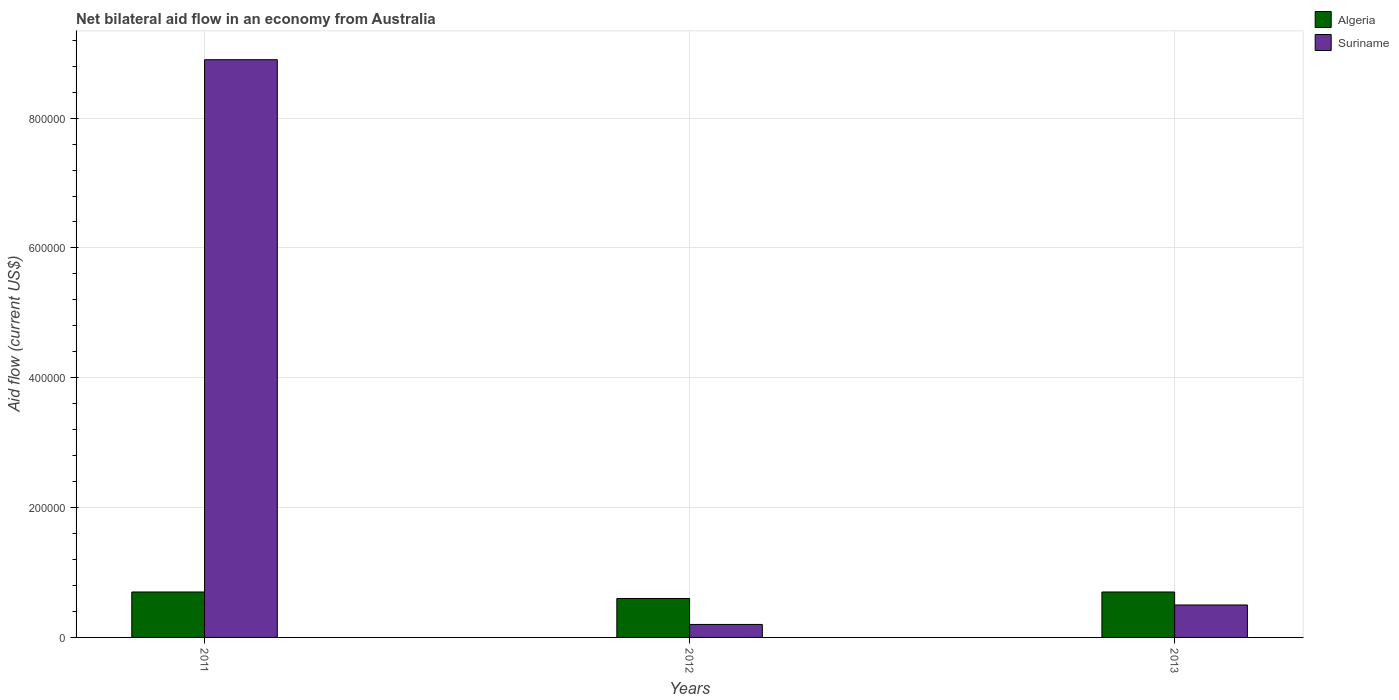Are the number of bars per tick equal to the number of legend labels?
Give a very brief answer. Yes. How many bars are there on the 1st tick from the right?
Your answer should be compact. 2. What is the label of the 3rd group of bars from the left?
Make the answer very short. 2013. Across all years, what is the maximum net bilateral aid flow in Suriname?
Your answer should be very brief. 8.90e+05. Across all years, what is the minimum net bilateral aid flow in Algeria?
Make the answer very short. 6.00e+04. In which year was the net bilateral aid flow in Suriname maximum?
Your answer should be very brief. 2011. What is the total net bilateral aid flow in Algeria in the graph?
Offer a very short reply. 2.00e+05. What is the difference between the net bilateral aid flow in Algeria in 2011 and the net bilateral aid flow in Suriname in 2012?
Give a very brief answer. 5.00e+04. In the year 2012, what is the difference between the net bilateral aid flow in Suriname and net bilateral aid flow in Algeria?
Make the answer very short. -4.00e+04. What is the difference between the highest and the second highest net bilateral aid flow in Algeria?
Offer a terse response. 0. What is the difference between the highest and the lowest net bilateral aid flow in Suriname?
Offer a terse response. 8.70e+05. In how many years, is the net bilateral aid flow in Algeria greater than the average net bilateral aid flow in Algeria taken over all years?
Offer a very short reply. 2. What does the 1st bar from the left in 2011 represents?
Provide a short and direct response. Algeria. What does the 2nd bar from the right in 2013 represents?
Your answer should be very brief. Algeria. How many years are there in the graph?
Offer a terse response. 3. What is the difference between two consecutive major ticks on the Y-axis?
Give a very brief answer. 2.00e+05. Are the values on the major ticks of Y-axis written in scientific E-notation?
Give a very brief answer. No. Does the graph contain any zero values?
Your answer should be compact. No. How are the legend labels stacked?
Give a very brief answer. Vertical. What is the title of the graph?
Make the answer very short. Net bilateral aid flow in an economy from Australia. What is the Aid flow (current US$) in Algeria in 2011?
Provide a short and direct response. 7.00e+04. What is the Aid flow (current US$) in Suriname in 2011?
Give a very brief answer. 8.90e+05. What is the Aid flow (current US$) of Algeria in 2012?
Offer a very short reply. 6.00e+04. What is the Aid flow (current US$) of Algeria in 2013?
Your response must be concise. 7.00e+04. Across all years, what is the maximum Aid flow (current US$) in Suriname?
Your response must be concise. 8.90e+05. Across all years, what is the minimum Aid flow (current US$) in Algeria?
Offer a very short reply. 6.00e+04. What is the total Aid flow (current US$) of Algeria in the graph?
Give a very brief answer. 2.00e+05. What is the total Aid flow (current US$) in Suriname in the graph?
Your answer should be compact. 9.60e+05. What is the difference between the Aid flow (current US$) of Suriname in 2011 and that in 2012?
Your response must be concise. 8.70e+05. What is the difference between the Aid flow (current US$) in Suriname in 2011 and that in 2013?
Keep it short and to the point. 8.40e+05. What is the difference between the Aid flow (current US$) in Algeria in 2012 and that in 2013?
Your answer should be very brief. -10000. What is the difference between the Aid flow (current US$) in Algeria in 2011 and the Aid flow (current US$) in Suriname in 2012?
Give a very brief answer. 5.00e+04. What is the difference between the Aid flow (current US$) of Algeria in 2011 and the Aid flow (current US$) of Suriname in 2013?
Your answer should be compact. 2.00e+04. What is the difference between the Aid flow (current US$) of Algeria in 2012 and the Aid flow (current US$) of Suriname in 2013?
Your answer should be very brief. 10000. What is the average Aid flow (current US$) of Algeria per year?
Make the answer very short. 6.67e+04. In the year 2011, what is the difference between the Aid flow (current US$) in Algeria and Aid flow (current US$) in Suriname?
Your answer should be compact. -8.20e+05. In the year 2012, what is the difference between the Aid flow (current US$) in Algeria and Aid flow (current US$) in Suriname?
Offer a very short reply. 4.00e+04. In the year 2013, what is the difference between the Aid flow (current US$) in Algeria and Aid flow (current US$) in Suriname?
Provide a succinct answer. 2.00e+04. What is the ratio of the Aid flow (current US$) of Suriname in 2011 to that in 2012?
Offer a terse response. 44.5. What is the ratio of the Aid flow (current US$) of Algeria in 2011 to that in 2013?
Offer a very short reply. 1. What is the ratio of the Aid flow (current US$) of Suriname in 2011 to that in 2013?
Your answer should be compact. 17.8. What is the difference between the highest and the second highest Aid flow (current US$) in Algeria?
Provide a short and direct response. 0. What is the difference between the highest and the second highest Aid flow (current US$) in Suriname?
Your response must be concise. 8.40e+05. What is the difference between the highest and the lowest Aid flow (current US$) of Suriname?
Your response must be concise. 8.70e+05. 